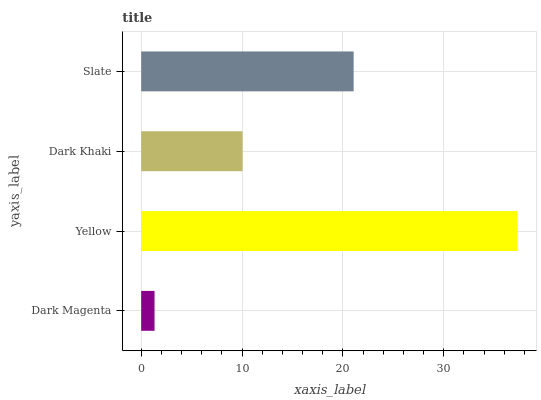Is Dark Magenta the minimum?
Answer yes or no. Yes. Is Yellow the maximum?
Answer yes or no. Yes. Is Dark Khaki the minimum?
Answer yes or no. No. Is Dark Khaki the maximum?
Answer yes or no. No. Is Yellow greater than Dark Khaki?
Answer yes or no. Yes. Is Dark Khaki less than Yellow?
Answer yes or no. Yes. Is Dark Khaki greater than Yellow?
Answer yes or no. No. Is Yellow less than Dark Khaki?
Answer yes or no. No. Is Slate the high median?
Answer yes or no. Yes. Is Dark Khaki the low median?
Answer yes or no. Yes. Is Dark Magenta the high median?
Answer yes or no. No. Is Dark Magenta the low median?
Answer yes or no. No. 